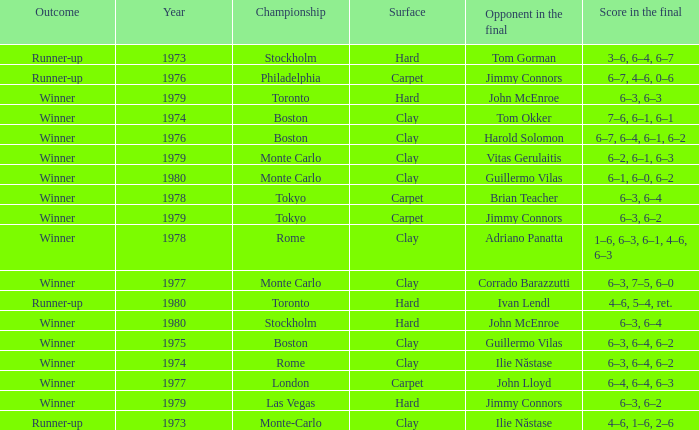Name the year for clay for boston and guillermo vilas 1975.0. Would you be able to parse every entry in this table? {'header': ['Outcome', 'Year', 'Championship', 'Surface', 'Opponent in the final', 'Score in the final'], 'rows': [['Runner-up', '1973', 'Stockholm', 'Hard', 'Tom Gorman', '3–6, 6–4, 6–7'], ['Runner-up', '1976', 'Philadelphia', 'Carpet', 'Jimmy Connors', '6–7, 4–6, 0–6'], ['Winner', '1979', 'Toronto', 'Hard', 'John McEnroe', '6–3, 6–3'], ['Winner', '1974', 'Boston', 'Clay', 'Tom Okker', '7–6, 6–1, 6–1'], ['Winner', '1976', 'Boston', 'Clay', 'Harold Solomon', '6–7, 6–4, 6–1, 6–2'], ['Winner', '1979', 'Monte Carlo', 'Clay', 'Vitas Gerulaitis', '6–2, 6–1, 6–3'], ['Winner', '1980', 'Monte Carlo', 'Clay', 'Guillermo Vilas', '6–1, 6–0, 6–2'], ['Winner', '1978', 'Tokyo', 'Carpet', 'Brian Teacher', '6–3, 6–4'], ['Winner', '1979', 'Tokyo', 'Carpet', 'Jimmy Connors', '6–3, 6–2'], ['Winner', '1978', 'Rome', 'Clay', 'Adriano Panatta', '1–6, 6–3, 6–1, 4–6, 6–3'], ['Winner', '1977', 'Monte Carlo', 'Clay', 'Corrado Barazzutti', '6–3, 7–5, 6–0'], ['Runner-up', '1980', 'Toronto', 'Hard', 'Ivan Lendl', '4–6, 5–4, ret.'], ['Winner', '1980', 'Stockholm', 'Hard', 'John McEnroe', '6–3, 6–4'], ['Winner', '1975', 'Boston', 'Clay', 'Guillermo Vilas', '6–3, 6–4, 6–2'], ['Winner', '1974', 'Rome', 'Clay', 'Ilie Năstase', '6–3, 6–4, 6–2'], ['Winner', '1977', 'London', 'Carpet', 'John Lloyd', '6–4, 6–4, 6–3'], ['Winner', '1979', 'Las Vegas', 'Hard', 'Jimmy Connors', '6–3, 6–2'], ['Runner-up', '1973', 'Monte-Carlo', 'Clay', 'Ilie Năstase', '4–6, 1–6, 2–6']]} 